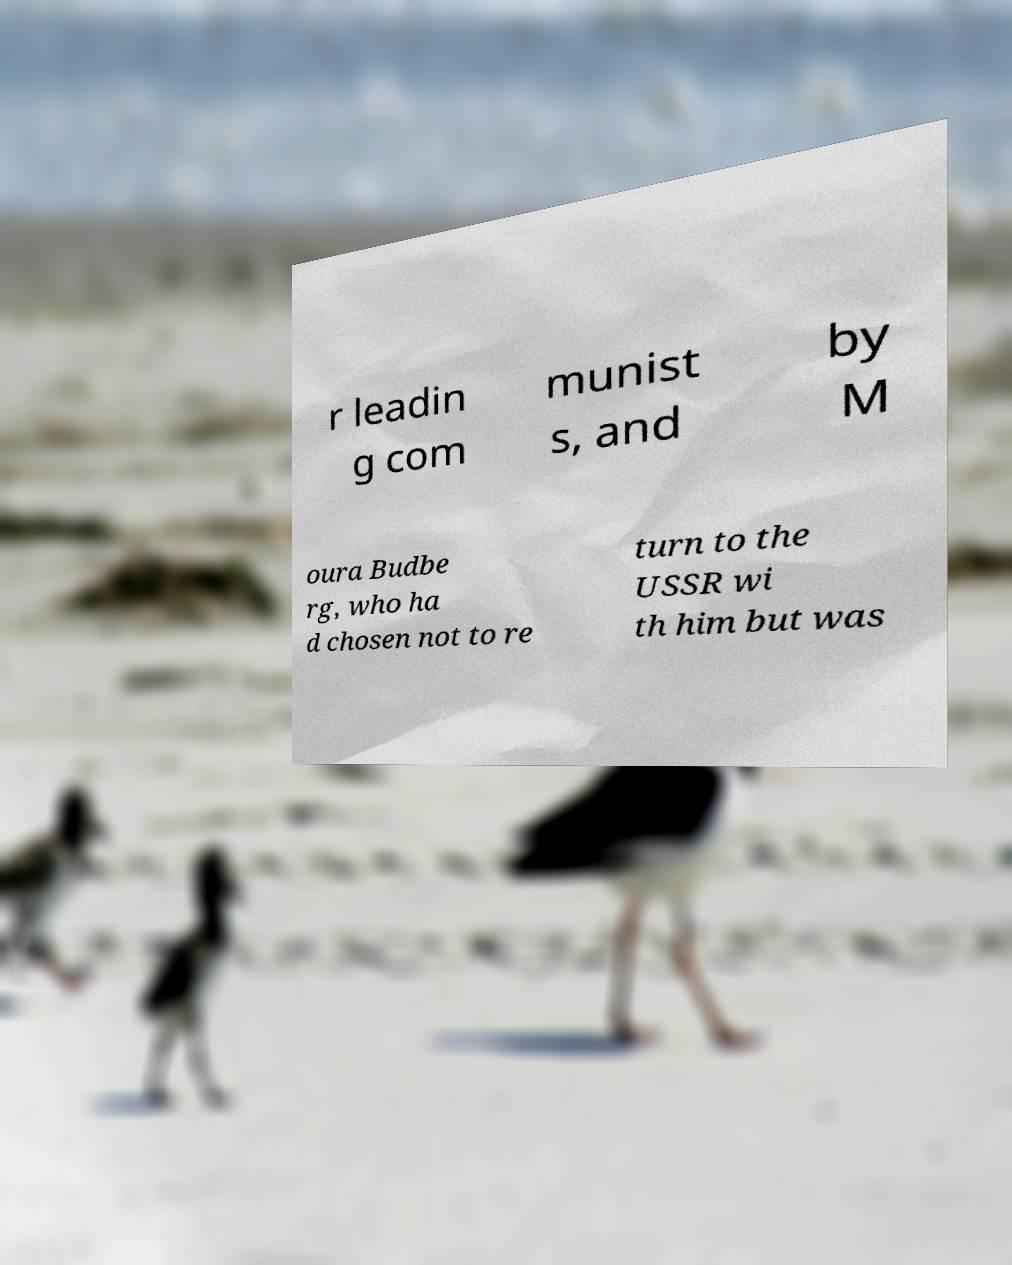I need the written content from this picture converted into text. Can you do that? r leadin g com munist s, and by M oura Budbe rg, who ha d chosen not to re turn to the USSR wi th him but was 